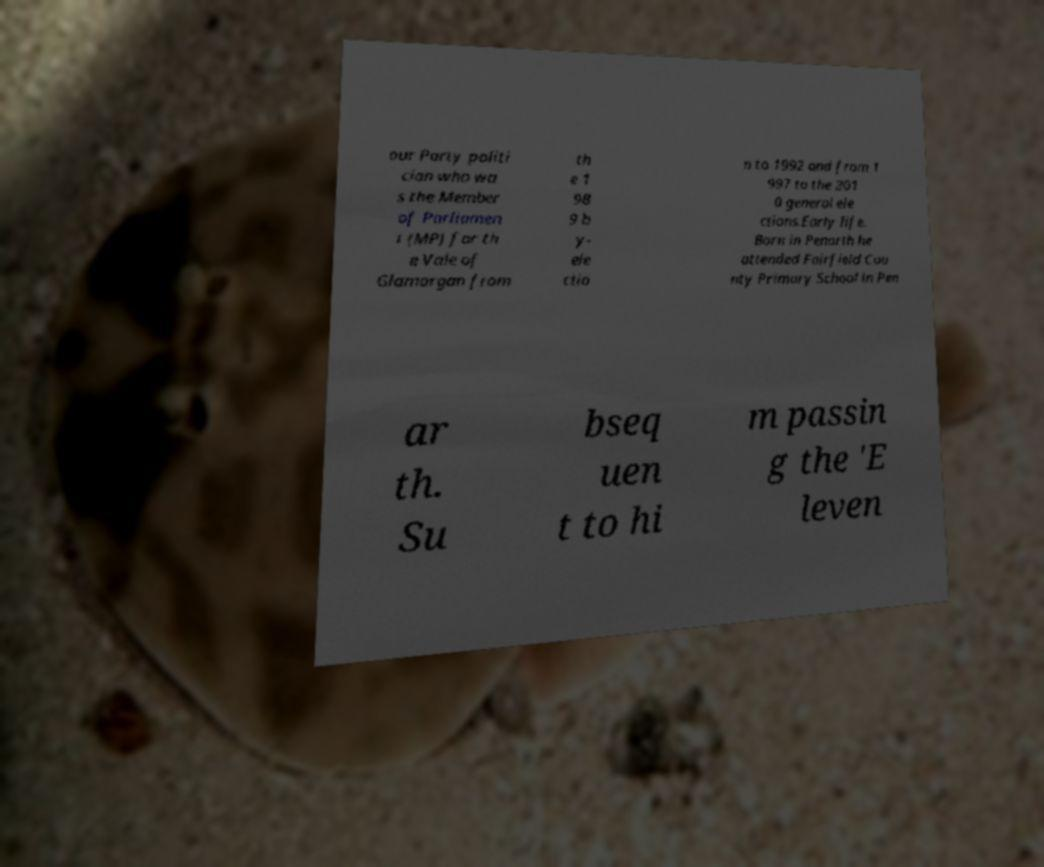There's text embedded in this image that I need extracted. Can you transcribe it verbatim? our Party politi cian who wa s the Member of Parliamen t (MP) for th e Vale of Glamorgan from th e 1 98 9 b y- ele ctio n to 1992 and from 1 997 to the 201 0 general ele ctions.Early life. Born in Penarth he attended Fairfield Cou nty Primary School in Pen ar th. Su bseq uen t to hi m passin g the 'E leven 